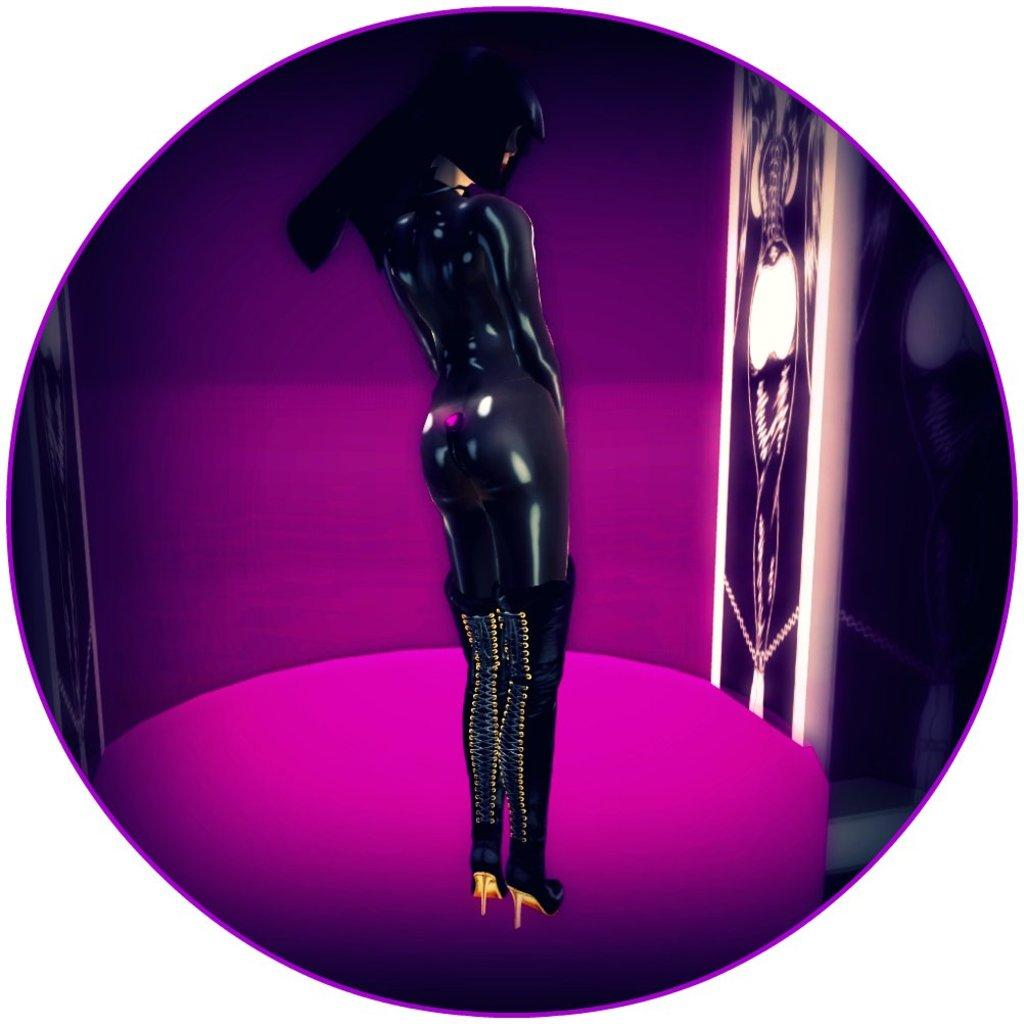What is the main subject of the image? There is a mannequin of a woman in the image. What color is the mannequin? The mannequin is black in color. What color is the background of the image? The background of the image is pink. What letter is the mannequin holding in the image? There is no letter present in the image; the mannequin is not holding anything. 